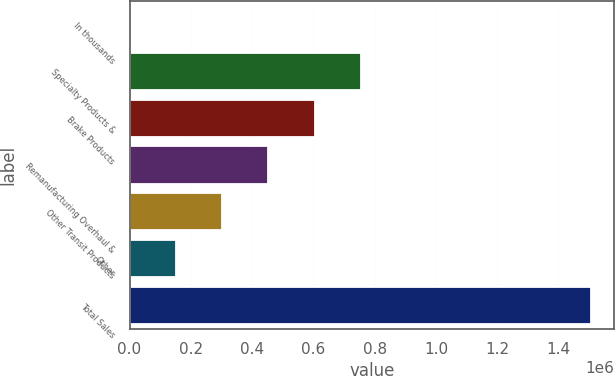<chart> <loc_0><loc_0><loc_500><loc_500><bar_chart><fcel>In thousands<fcel>Specialty Products &<fcel>Brake Products<fcel>Remanufacturing Overhaul &<fcel>Other Transit Products<fcel>Other<fcel>Total Sales<nl><fcel>2010<fcel>754511<fcel>604011<fcel>453511<fcel>303010<fcel>152510<fcel>1.50701e+06<nl></chart> 